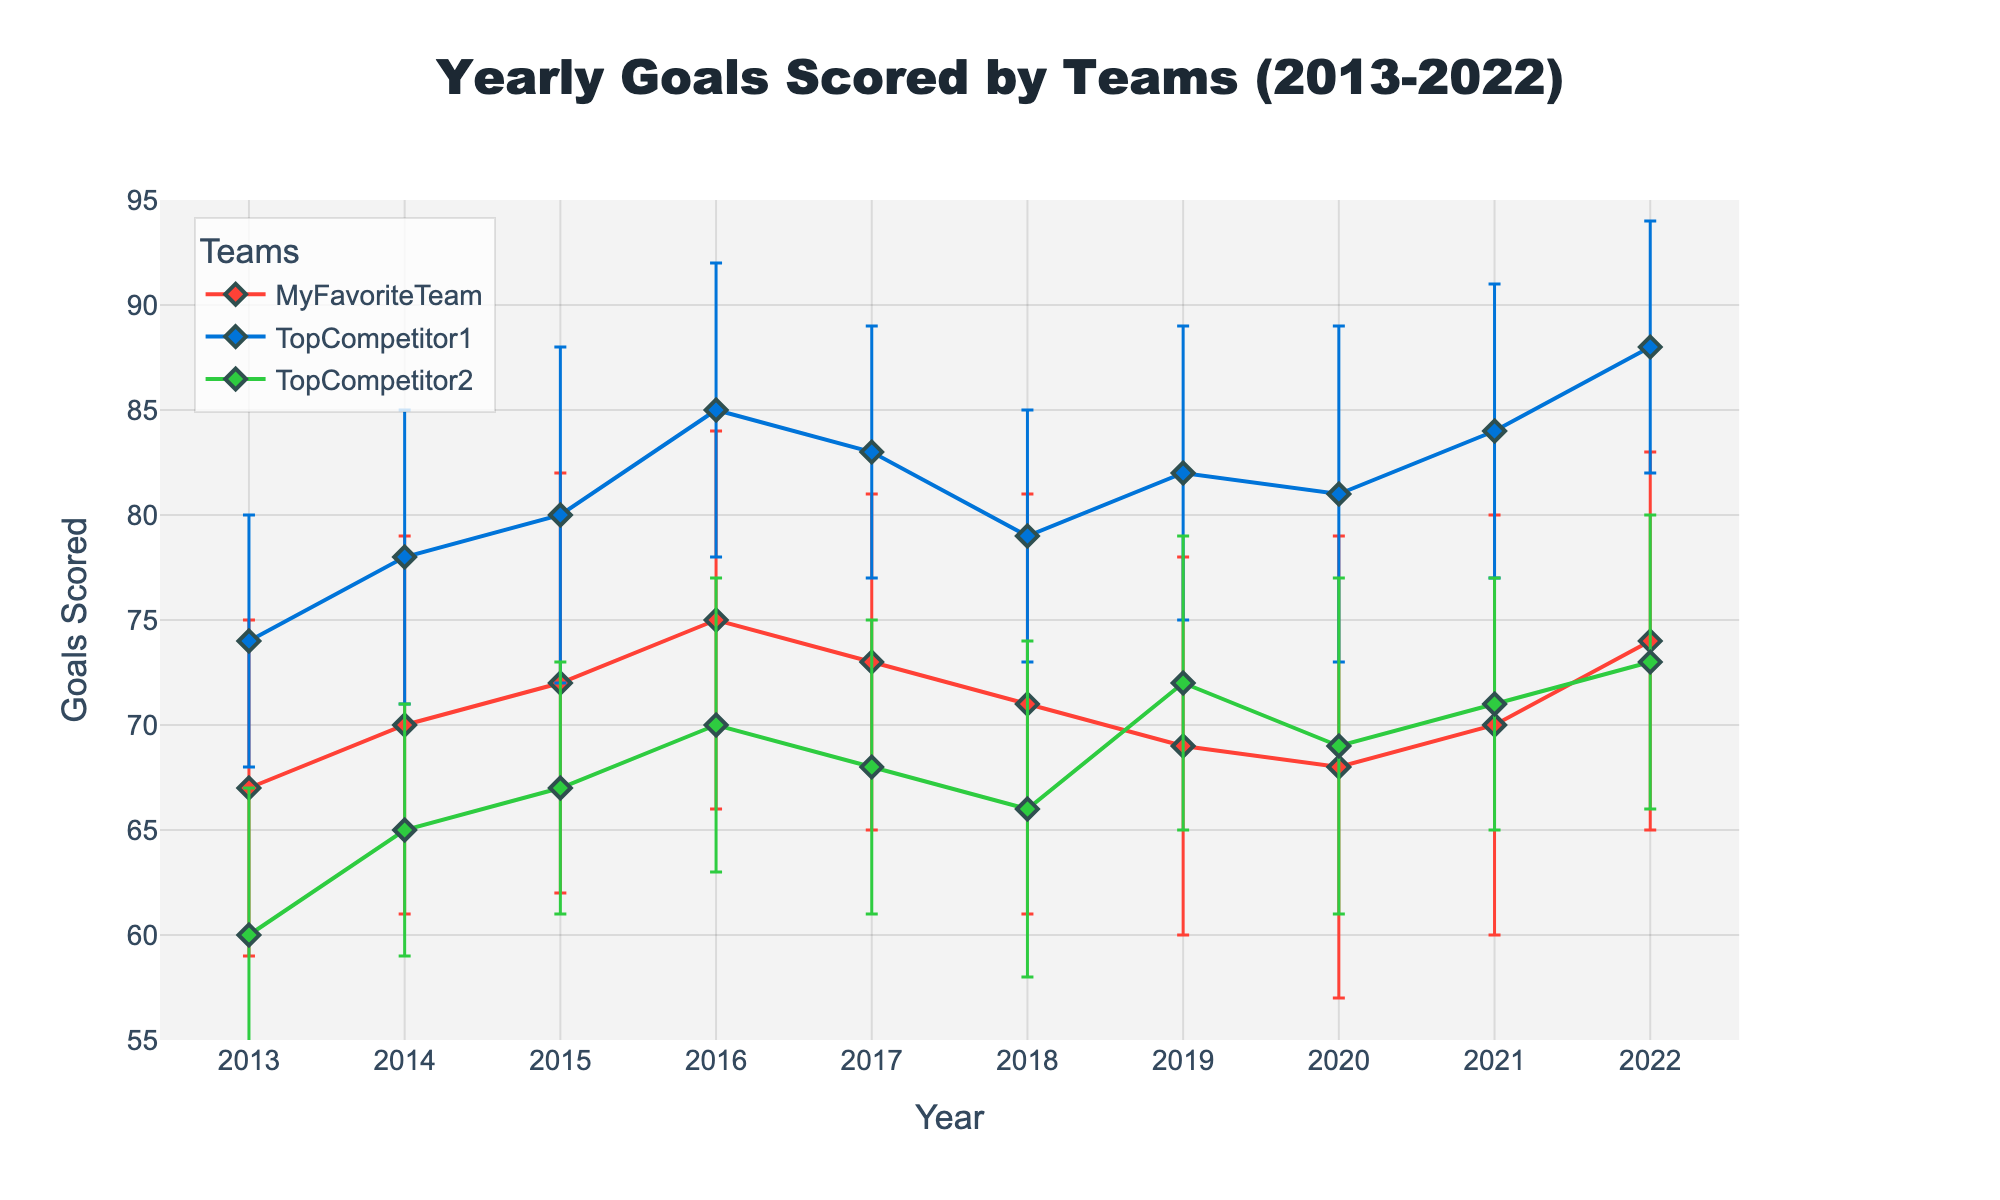What's the title of the plot? The title of the plot is usually positioned at the top of the figure, centered and in larger font size compared to other text elements. It helps viewers quickly understand what the plot represents.
Answer: Yearly Goals Scored by Teams (2013-2022) How many teams are represented in the plot? By looking at the legend or the different lines on the plot, we can identify the number of teams represented. Each line corresponds to a different team.
Answer: 3 In which year did MyFavoriteTeam score the most goals? Identify the highest point on the plot corresponding to MyFavoriteTeam's line. Cross-reference it with the x-axis to find the corresponding year.
Answer: 2016 Which team has more goals in 2019? MyFavoriteTeam or TopCompetitor2? Compare the y-values of MyFavoriteTeam and TopCompetitor2 for the year 2019 on the plot to determine which is higher.
Answer: TopCompetitor2 What is the variance of goals for MyFavoriteTeam in 2020? Variance is indicated by the error bars for each data point. Look at the error bar for MyFavoriteTeam in the year 2020.
Answer: 11 Which team shows the most consistent performance (least variance) over the years? Consistency can be evaluated by the size of error bars. Smaller error bars indicate less variance. Compare error bars for all teams across the years.
Answer: TopCompetitor1 What is the trend of MyFavoriteTeam's yearly goals from 2013 to 2022? Observe the general direction of MyFavoriteTeam's line over the years to describe the trend. Whether it is increasing, decreasing, or fluctuating can be identified.
Answer: Fluctuating How does the performance of TopCompetitor1 in 2022 compare to 2013? Compare the y-values of TopCompetitor1 for the years 2013 and 2022 to see whether their performance has improved or declined.
Answer: Improved What is the average number of goals scored by MyFavoriteTeam from 2013 to 2022? Sum all the yearly goals for MyFavoriteTeam and divide by the number of years (10). (67 + 70 + 72 + 75 + 73 + 71 + 69 + 68 + 70 + 74)/10 = 709/10 = 70.9
Answer: 70.9 In which year is the difference in goals between MyFavoriteTeam and TopCompetitor1 the largest? Calculate the absolute differences in yearly goals for MyFavoriteTeam and TopCompetitor1 across all years and identify the year with the largest difference.
Answer: 2022 